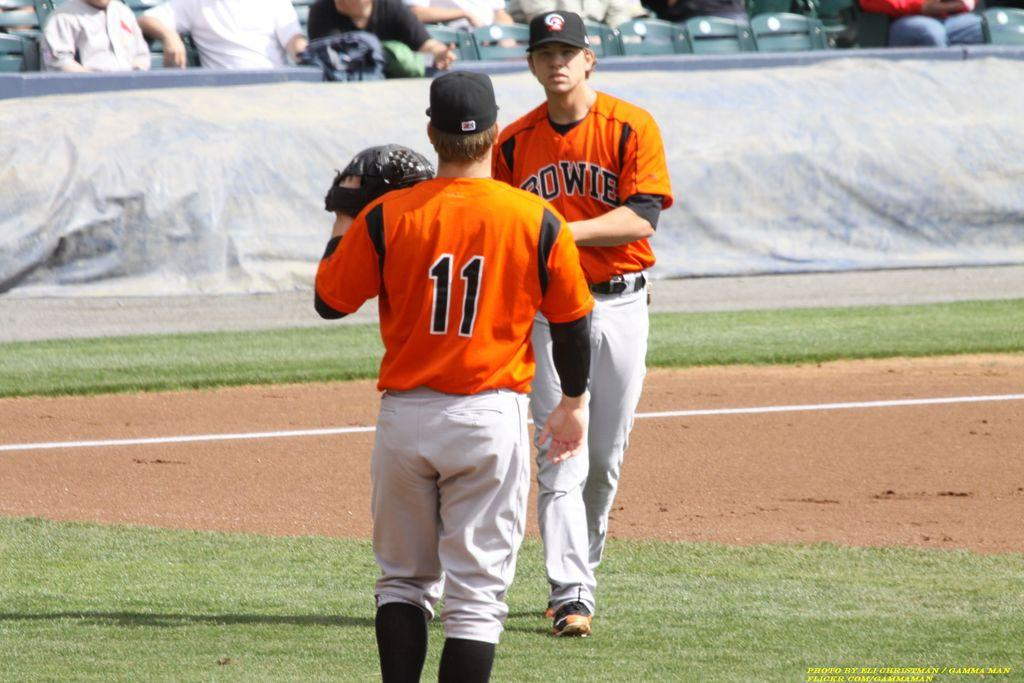<image>
Share a concise interpretation of the image provided. Two Bowie baseball players, one of them number 11, on the field. 